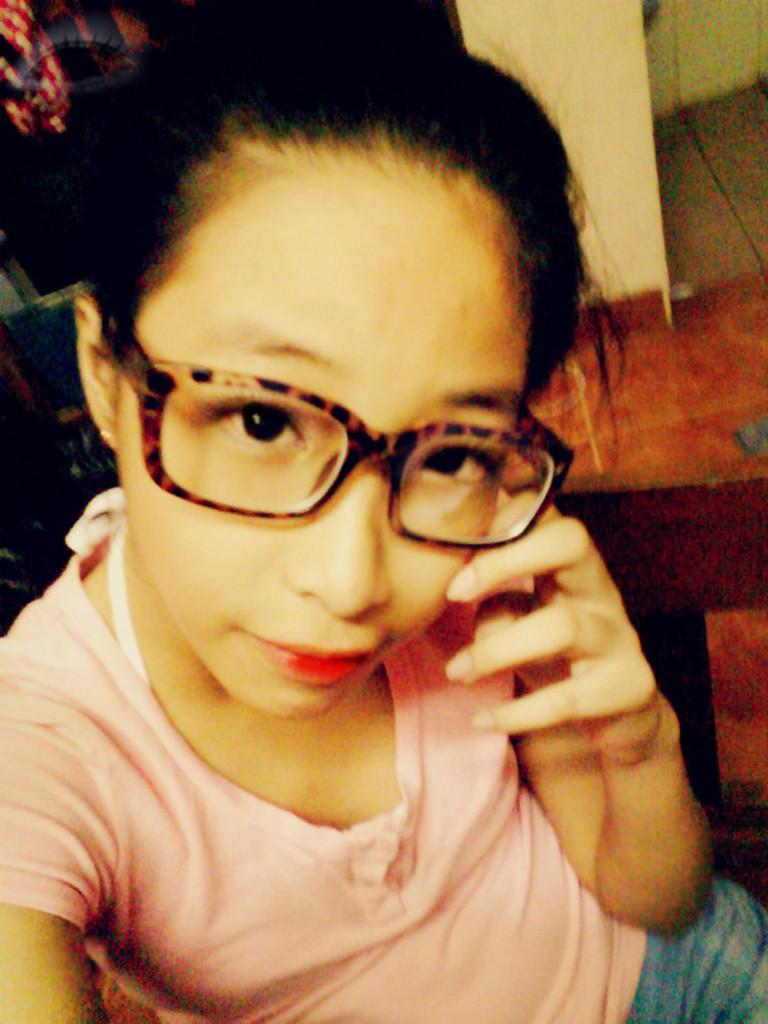Who is the main subject in the image? There is a lady in the image. What is the lady doing in the image? The lady is sitting on a chair. What accessory is the lady wearing in the image? The lady is wearing glasses. What can be seen in the background of the image? There is a wall in the background of the image. What type of waves can be seen crashing against the shore in the image? There are no waves present in the image; it features a lady sitting on a chair with a wall in the background. 